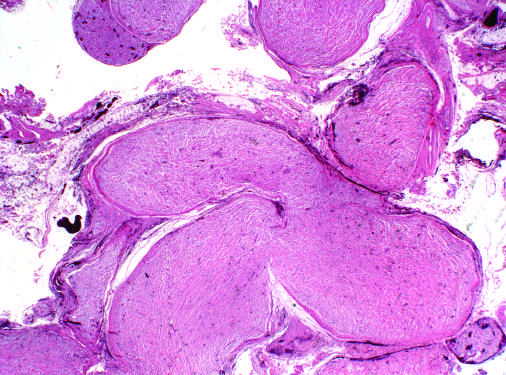what are expanded by infiltrating tumor cells?
Answer the question using a single word or phrase. Multiple nerve fascicles 